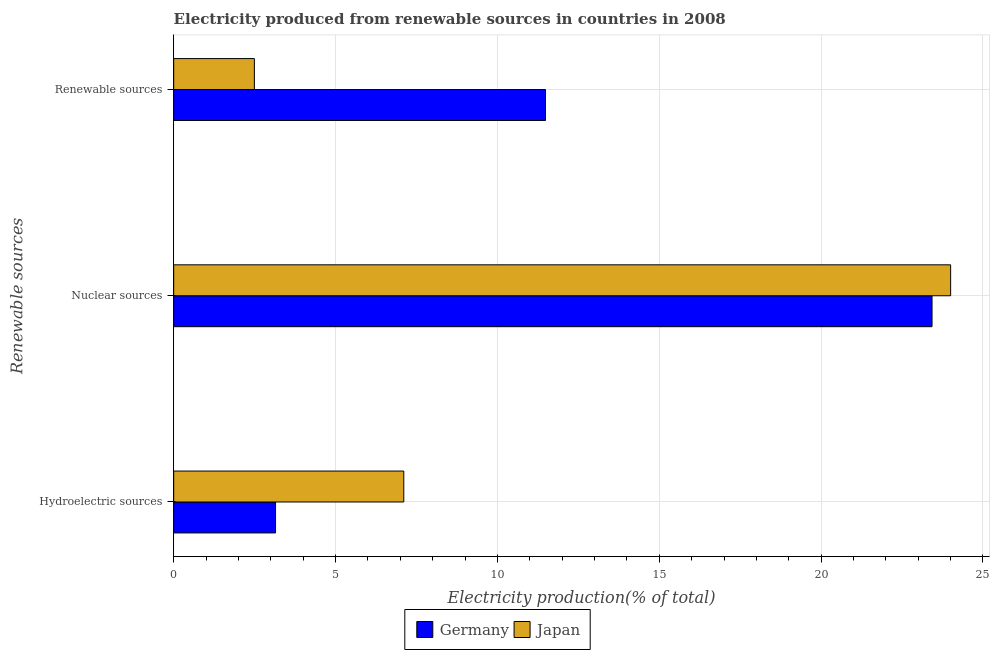How many different coloured bars are there?
Your answer should be very brief. 2. Are the number of bars per tick equal to the number of legend labels?
Make the answer very short. Yes. How many bars are there on the 3rd tick from the bottom?
Offer a terse response. 2. What is the label of the 2nd group of bars from the top?
Offer a very short reply. Nuclear sources. What is the percentage of electricity produced by hydroelectric sources in Japan?
Your answer should be very brief. 7.11. Across all countries, what is the maximum percentage of electricity produced by nuclear sources?
Your answer should be compact. 24. Across all countries, what is the minimum percentage of electricity produced by renewable sources?
Your answer should be very brief. 2.49. In which country was the percentage of electricity produced by hydroelectric sources maximum?
Your answer should be compact. Japan. In which country was the percentage of electricity produced by renewable sources minimum?
Your response must be concise. Japan. What is the total percentage of electricity produced by nuclear sources in the graph?
Provide a succinct answer. 47.43. What is the difference between the percentage of electricity produced by hydroelectric sources in Japan and that in Germany?
Your response must be concise. 3.96. What is the difference between the percentage of electricity produced by renewable sources in Germany and the percentage of electricity produced by hydroelectric sources in Japan?
Keep it short and to the point. 4.38. What is the average percentage of electricity produced by hydroelectric sources per country?
Make the answer very short. 5.13. What is the difference between the percentage of electricity produced by nuclear sources and percentage of electricity produced by renewable sources in Japan?
Offer a terse response. 21.51. In how many countries, is the percentage of electricity produced by renewable sources greater than 23 %?
Make the answer very short. 0. What is the ratio of the percentage of electricity produced by renewable sources in Japan to that in Germany?
Your answer should be very brief. 0.22. Is the percentage of electricity produced by nuclear sources in Germany less than that in Japan?
Offer a terse response. Yes. What is the difference between the highest and the second highest percentage of electricity produced by hydroelectric sources?
Provide a short and direct response. 3.96. What is the difference between the highest and the lowest percentage of electricity produced by hydroelectric sources?
Keep it short and to the point. 3.96. In how many countries, is the percentage of electricity produced by nuclear sources greater than the average percentage of electricity produced by nuclear sources taken over all countries?
Your response must be concise. 1. How many bars are there?
Your response must be concise. 6. Are all the bars in the graph horizontal?
Provide a succinct answer. Yes. How many countries are there in the graph?
Your response must be concise. 2. What is the difference between two consecutive major ticks on the X-axis?
Your answer should be very brief. 5. Does the graph contain any zero values?
Your response must be concise. No. Does the graph contain grids?
Offer a very short reply. Yes. What is the title of the graph?
Your answer should be compact. Electricity produced from renewable sources in countries in 2008. Does "Cuba" appear as one of the legend labels in the graph?
Offer a very short reply. No. What is the label or title of the X-axis?
Provide a short and direct response. Electricity production(% of total). What is the label or title of the Y-axis?
Your answer should be compact. Renewable sources. What is the Electricity production(% of total) in Germany in Hydroelectric sources?
Provide a succinct answer. 3.15. What is the Electricity production(% of total) of Japan in Hydroelectric sources?
Make the answer very short. 7.11. What is the Electricity production(% of total) of Germany in Nuclear sources?
Your response must be concise. 23.43. What is the Electricity production(% of total) in Japan in Nuclear sources?
Offer a terse response. 24. What is the Electricity production(% of total) in Germany in Renewable sources?
Keep it short and to the point. 11.49. What is the Electricity production(% of total) of Japan in Renewable sources?
Provide a short and direct response. 2.49. Across all Renewable sources, what is the maximum Electricity production(% of total) of Germany?
Provide a succinct answer. 23.43. Across all Renewable sources, what is the maximum Electricity production(% of total) of Japan?
Your response must be concise. 24. Across all Renewable sources, what is the minimum Electricity production(% of total) in Germany?
Give a very brief answer. 3.15. Across all Renewable sources, what is the minimum Electricity production(% of total) of Japan?
Ensure brevity in your answer.  2.49. What is the total Electricity production(% of total) of Germany in the graph?
Provide a succinct answer. 38.06. What is the total Electricity production(% of total) in Japan in the graph?
Provide a short and direct response. 33.6. What is the difference between the Electricity production(% of total) in Germany in Hydroelectric sources and that in Nuclear sources?
Provide a short and direct response. -20.28. What is the difference between the Electricity production(% of total) of Japan in Hydroelectric sources and that in Nuclear sources?
Provide a succinct answer. -16.89. What is the difference between the Electricity production(% of total) of Germany in Hydroelectric sources and that in Renewable sources?
Keep it short and to the point. -8.34. What is the difference between the Electricity production(% of total) in Japan in Hydroelectric sources and that in Renewable sources?
Keep it short and to the point. 4.62. What is the difference between the Electricity production(% of total) in Germany in Nuclear sources and that in Renewable sources?
Your response must be concise. 11.94. What is the difference between the Electricity production(% of total) in Japan in Nuclear sources and that in Renewable sources?
Offer a terse response. 21.51. What is the difference between the Electricity production(% of total) of Germany in Hydroelectric sources and the Electricity production(% of total) of Japan in Nuclear sources?
Give a very brief answer. -20.85. What is the difference between the Electricity production(% of total) in Germany in Hydroelectric sources and the Electricity production(% of total) in Japan in Renewable sources?
Provide a succinct answer. 0.65. What is the difference between the Electricity production(% of total) of Germany in Nuclear sources and the Electricity production(% of total) of Japan in Renewable sources?
Your response must be concise. 20.93. What is the average Electricity production(% of total) of Germany per Renewable sources?
Give a very brief answer. 12.69. What is the average Electricity production(% of total) of Japan per Renewable sources?
Your answer should be compact. 11.2. What is the difference between the Electricity production(% of total) in Germany and Electricity production(% of total) in Japan in Hydroelectric sources?
Your answer should be very brief. -3.96. What is the difference between the Electricity production(% of total) of Germany and Electricity production(% of total) of Japan in Nuclear sources?
Your answer should be compact. -0.57. What is the difference between the Electricity production(% of total) of Germany and Electricity production(% of total) of Japan in Renewable sources?
Keep it short and to the point. 8.99. What is the ratio of the Electricity production(% of total) in Germany in Hydroelectric sources to that in Nuclear sources?
Ensure brevity in your answer.  0.13. What is the ratio of the Electricity production(% of total) in Japan in Hydroelectric sources to that in Nuclear sources?
Offer a very short reply. 0.3. What is the ratio of the Electricity production(% of total) of Germany in Hydroelectric sources to that in Renewable sources?
Your answer should be compact. 0.27. What is the ratio of the Electricity production(% of total) in Japan in Hydroelectric sources to that in Renewable sources?
Provide a succinct answer. 2.85. What is the ratio of the Electricity production(% of total) in Germany in Nuclear sources to that in Renewable sources?
Ensure brevity in your answer.  2.04. What is the ratio of the Electricity production(% of total) in Japan in Nuclear sources to that in Renewable sources?
Provide a short and direct response. 9.63. What is the difference between the highest and the second highest Electricity production(% of total) in Germany?
Your response must be concise. 11.94. What is the difference between the highest and the second highest Electricity production(% of total) in Japan?
Your response must be concise. 16.89. What is the difference between the highest and the lowest Electricity production(% of total) in Germany?
Keep it short and to the point. 20.28. What is the difference between the highest and the lowest Electricity production(% of total) of Japan?
Offer a terse response. 21.51. 